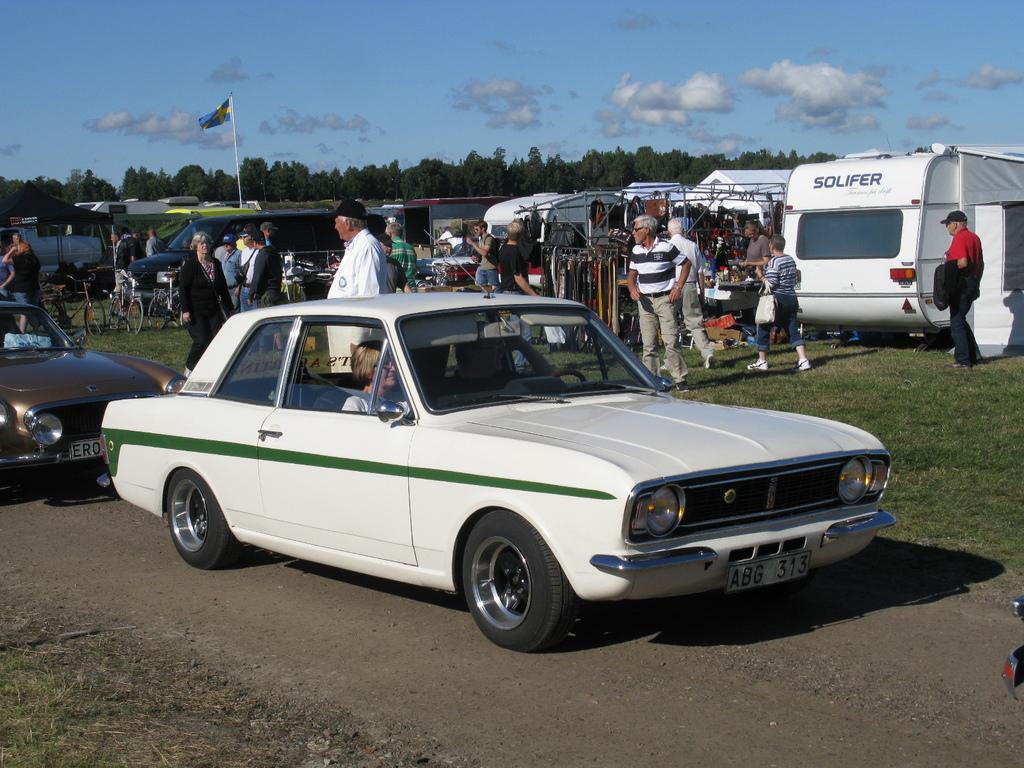Can you describe this image briefly? In this image I can see many vehicles and also bicycles. I can see one person is in the vehicle. To the side of these vehicles I can see the group of people standing and wearing the different color dresses. I can also see some stalls on the ground. In the background I can see the flag, many trees, clouds and the sky. 